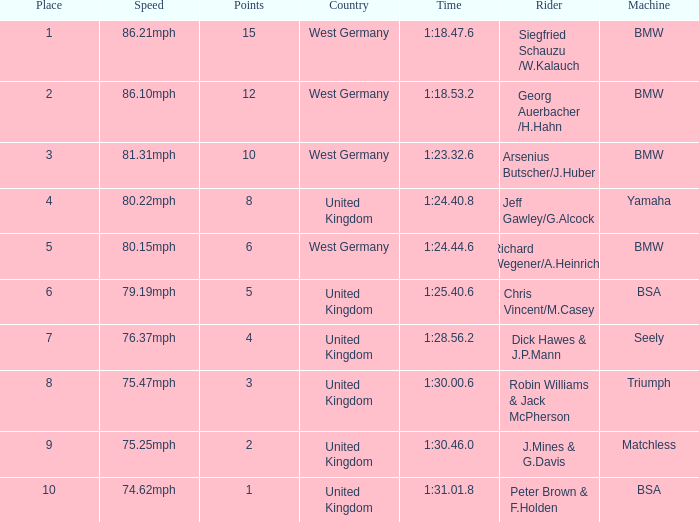Which place has points larger than 1, a bmw machine, and a time of 1:18.47.6? 1.0. 